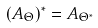<formula> <loc_0><loc_0><loc_500><loc_500>( A _ { \Theta } ) ^ { * } = A _ { \Theta ^ { * } }</formula> 